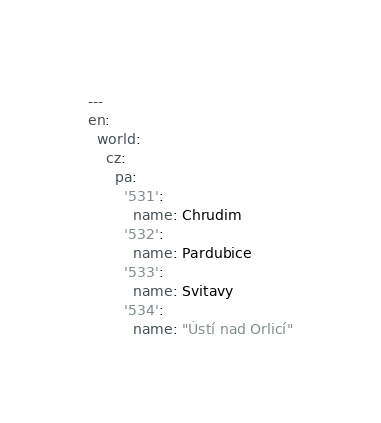Convert code to text. <code><loc_0><loc_0><loc_500><loc_500><_YAML_>---
en:
  world:
    cz:
      pa:
        '531':
          name: Chrudim
        '532':
          name: Pardubice
        '533':
          name: Svitavy
        '534':
          name: "Ústí nad Orlicí"
</code> 